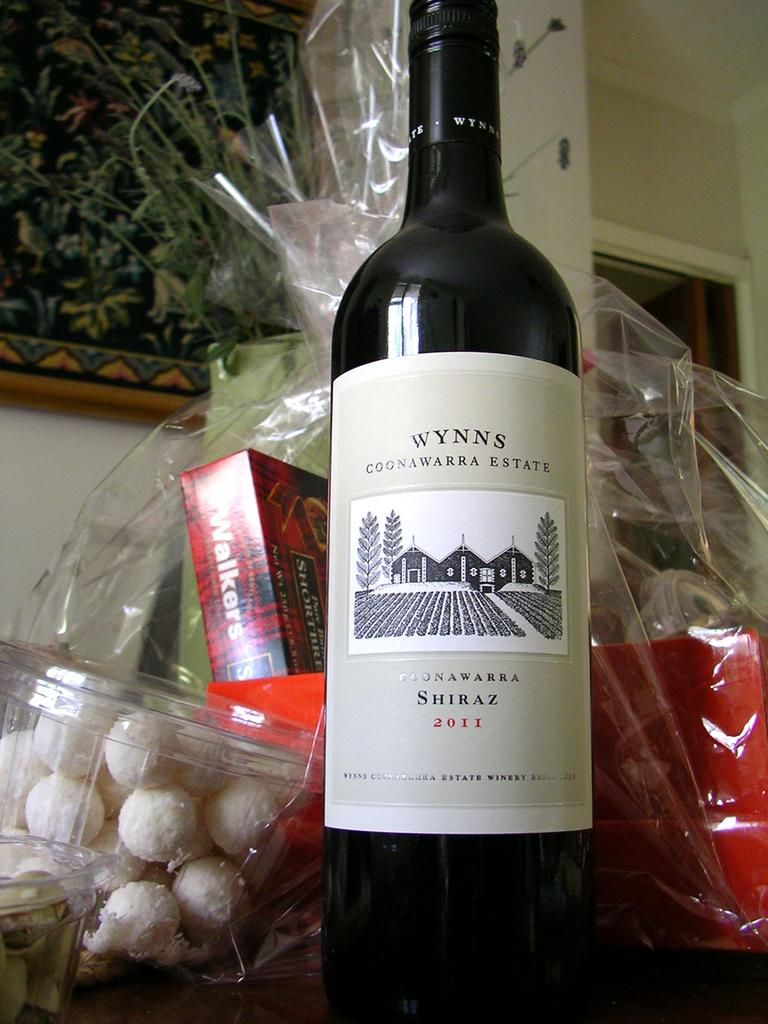<image>
Offer a succinct explanation of the picture presented. A ottle of Wynns Shiraz in front of a gift bag. 